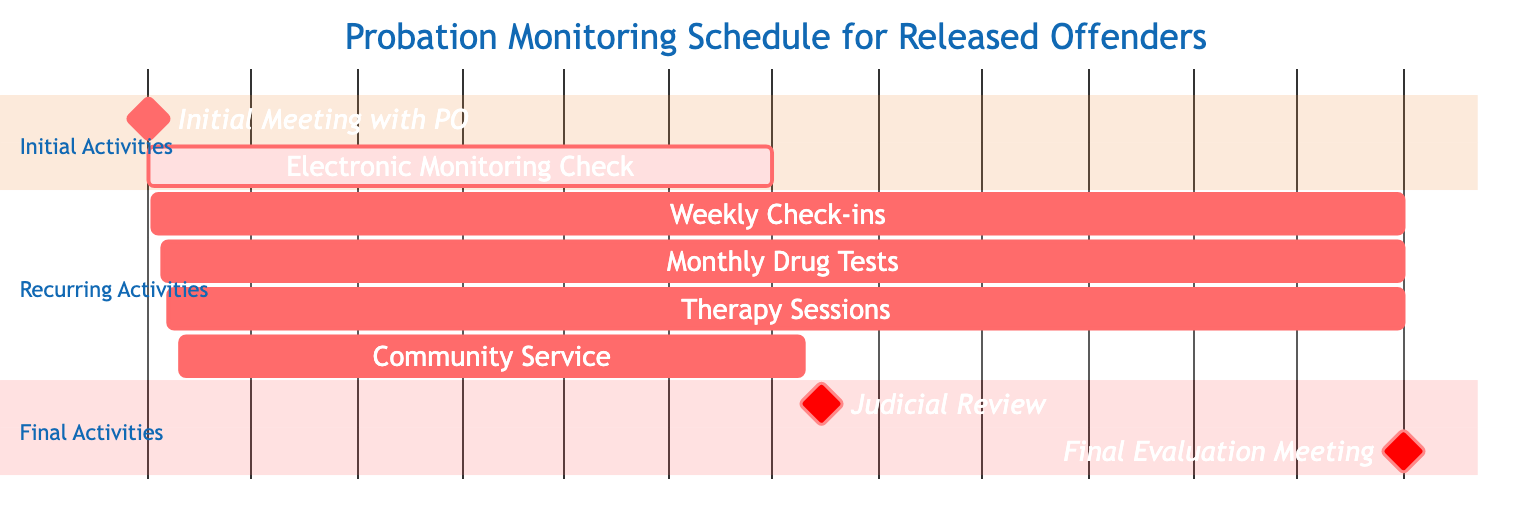What is the start date of the Initial Meeting with Probation Officer? The start date for the task "Initial Meeting with Probation Officer" is provided as "2023-11-01."
Answer: 2023-11-01 How long does the Community Service task last? The task "Community Service" starts on "2023-11-10" and ends on "2024-05-10." Counting the dates gives a duration of approximately 6 months.
Answer: 6 months Which task is responsible for Electronic Monitoring Check? The node labeled "Electronic Monitoring Check" indicates the responsible party is the "Tech Support Team."
Answer: Tech Support Team What frequency is set for Monthly Drug Tests? The frequency listed for "Monthly Drug Tests" is "Monthly," indicating the tests occur once a month.
Answer: Monthly What activities require a responsible party from the Testing Facility? The only activity listed under the Testing Facility is "Monthly Drug Tests," indicating it is the sole task for this party.
Answer: Monthly Drug Tests Which task is scheduled on the same date as the Judicial Review? The "Judicial Review" is scheduled on "2024-05-15," and there are no other tasks listed on that date, making it a unique event.
Answer: None How many tasks have check-in activities scheduled? Upon reviewing the tasks, there is one task with weekly check-in activities known as "Weekly Check-ins." Therefore, the total count is "1."
Answer: 1 What is the duration between the Initial Meeting and the Final Evaluation Meeting? The "Initial Meeting" takes place on "2023-11-01," and the "Final Evaluation Meeting" is set for "2024-11-01." Calculating the time between the two dates gives a duration of 12 months.
Answer: 12 months 